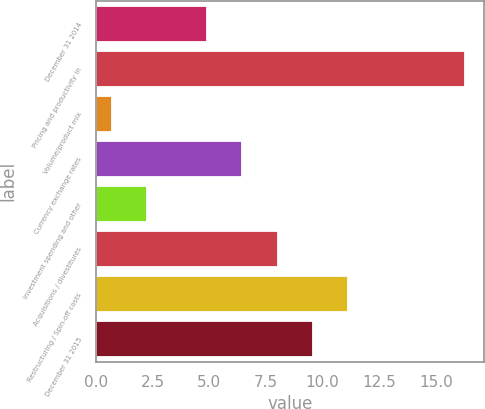Convert chart to OTSL. <chart><loc_0><loc_0><loc_500><loc_500><bar_chart><fcel>December 31 2014<fcel>Pricing and productivity in<fcel>Volume/product mix<fcel>Currency exchange rates<fcel>Investment spending and other<fcel>Acquisitions / divestitures<fcel>Restructuring / Spin-off costs<fcel>December 31 2015<nl><fcel>4.9<fcel>16.3<fcel>0.7<fcel>6.46<fcel>2.26<fcel>8.02<fcel>11.14<fcel>9.58<nl></chart> 